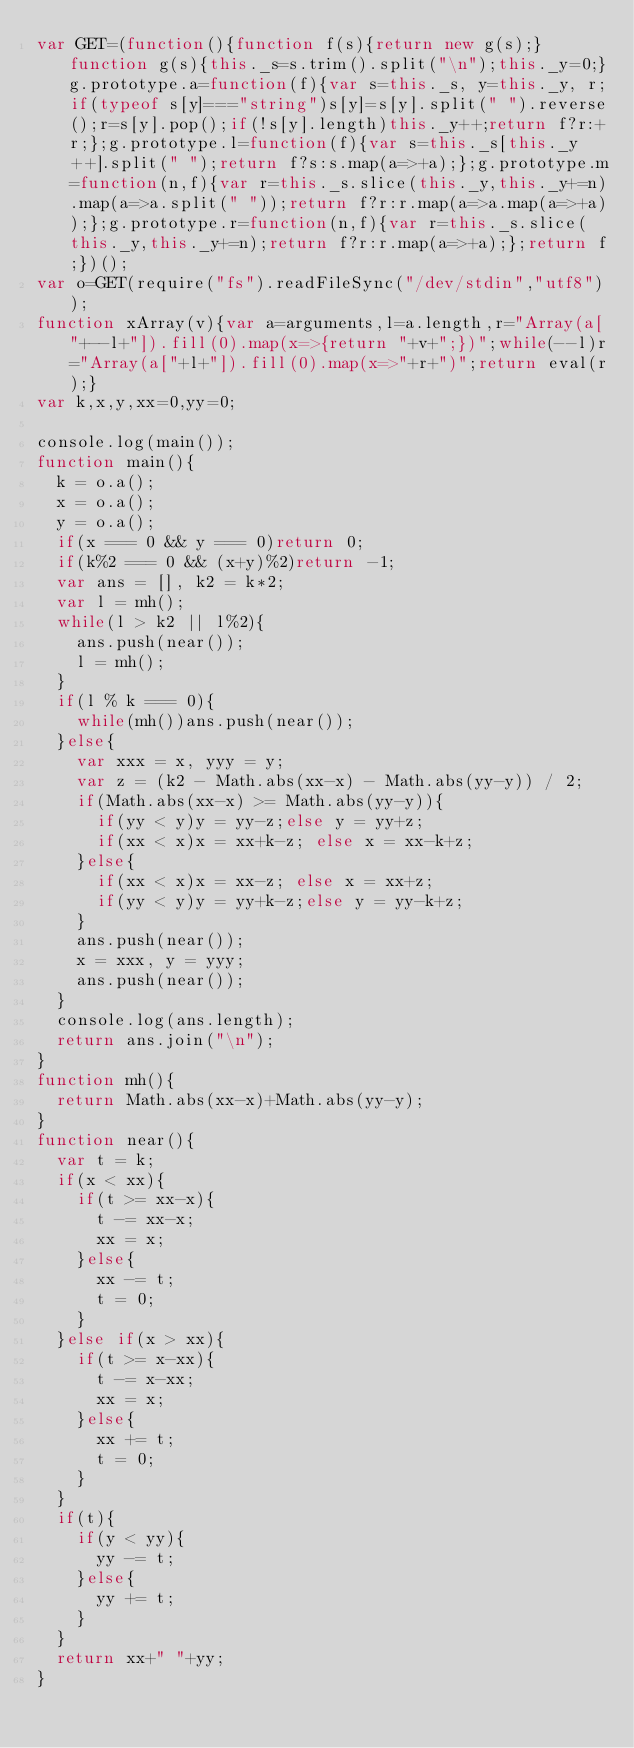Convert code to text. <code><loc_0><loc_0><loc_500><loc_500><_JavaScript_>var GET=(function(){function f(s){return new g(s);}function g(s){this._s=s.trim().split("\n");this._y=0;}g.prototype.a=function(f){var s=this._s, y=this._y, r;if(typeof s[y]==="string")s[y]=s[y].split(" ").reverse();r=s[y].pop();if(!s[y].length)this._y++;return f?r:+r;};g.prototype.l=function(f){var s=this._s[this._y++].split(" ");return f?s:s.map(a=>+a);};g.prototype.m=function(n,f){var r=this._s.slice(this._y,this._y+=n).map(a=>a.split(" "));return f?r:r.map(a=>a.map(a=>+a));};g.prototype.r=function(n,f){var r=this._s.slice(this._y,this._y+=n);return f?r:r.map(a=>+a);};return f;})();
var o=GET(require("fs").readFileSync("/dev/stdin","utf8"));
function xArray(v){var a=arguments,l=a.length,r="Array(a["+--l+"]).fill(0).map(x=>{return "+v+";})";while(--l)r="Array(a["+l+"]).fill(0).map(x=>"+r+")";return eval(r);}
var k,x,y,xx=0,yy=0;

console.log(main());
function main(){
  k = o.a();
  x = o.a();
  y = o.a();
  if(x === 0 && y === 0)return 0;
  if(k%2 === 0 && (x+y)%2)return -1;
  var ans = [], k2 = k*2;
  var l = mh();
  while(l > k2 || l%2){
    ans.push(near());
    l = mh();
  }
  if(l % k === 0){
    while(mh())ans.push(near());
  }else{
    var xxx = x, yyy = y;
    var z = (k2 - Math.abs(xx-x) - Math.abs(yy-y)) / 2;
    if(Math.abs(xx-x) >= Math.abs(yy-y)){
      if(yy < y)y = yy-z;else y = yy+z;
      if(xx < x)x = xx+k-z; else x = xx-k+z;
    }else{
      if(xx < x)x = xx-z; else x = xx+z;
      if(yy < y)y = yy+k-z;else y = yy-k+z;
    }
    ans.push(near());
    x = xxx, y = yyy;
    ans.push(near());
  }
  console.log(ans.length);
  return ans.join("\n");
}
function mh(){
  return Math.abs(xx-x)+Math.abs(yy-y);
}
function near(){
  var t = k;
  if(x < xx){
    if(t >= xx-x){
      t -= xx-x;
      xx = x;
    }else{
      xx -= t;
      t = 0;
    }
  }else if(x > xx){
    if(t >= x-xx){
      t -= x-xx;
      xx = x;
    }else{
      xx += t;
      t = 0;
    }
  }
  if(t){
    if(y < yy){
      yy -= t;
    }else{
      yy += t;
    }
  }
  return xx+" "+yy;
}</code> 